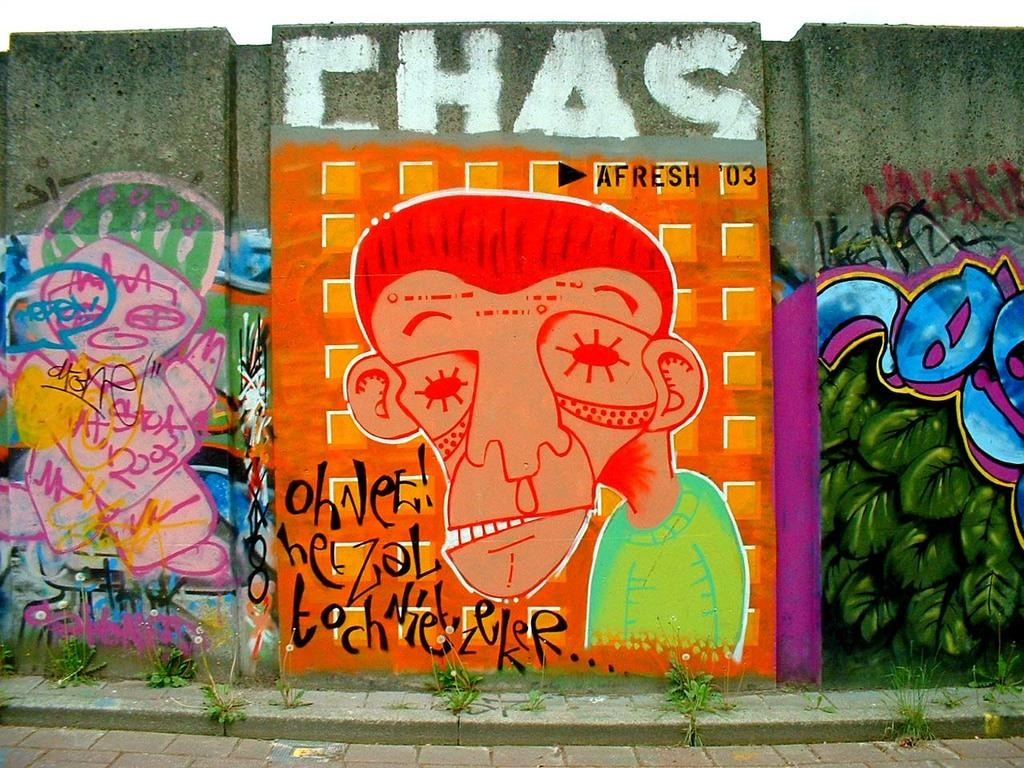What can be seen on the walls in the image? There are paintings on the walls in the image. What type of vegetation is present in the image? There are shrubs in the image. How many rings are visible on the shrubs in the image? There are no rings present on the shrubs in the image. What type of underwear is hanging on the paintings in the image? There is no underwear present in the image; it only features paintings on the walls and shrubs. 